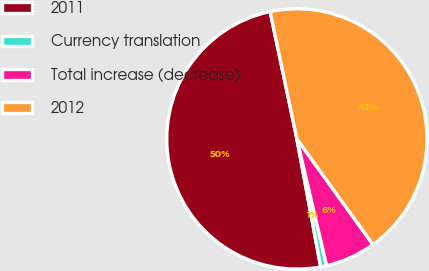Convert chart. <chart><loc_0><loc_0><loc_500><loc_500><pie_chart><fcel>2011<fcel>Currency translation<fcel>Total increase (decrease)<fcel>2012<nl><fcel>49.63%<fcel>0.74%<fcel>6.27%<fcel>43.36%<nl></chart> 